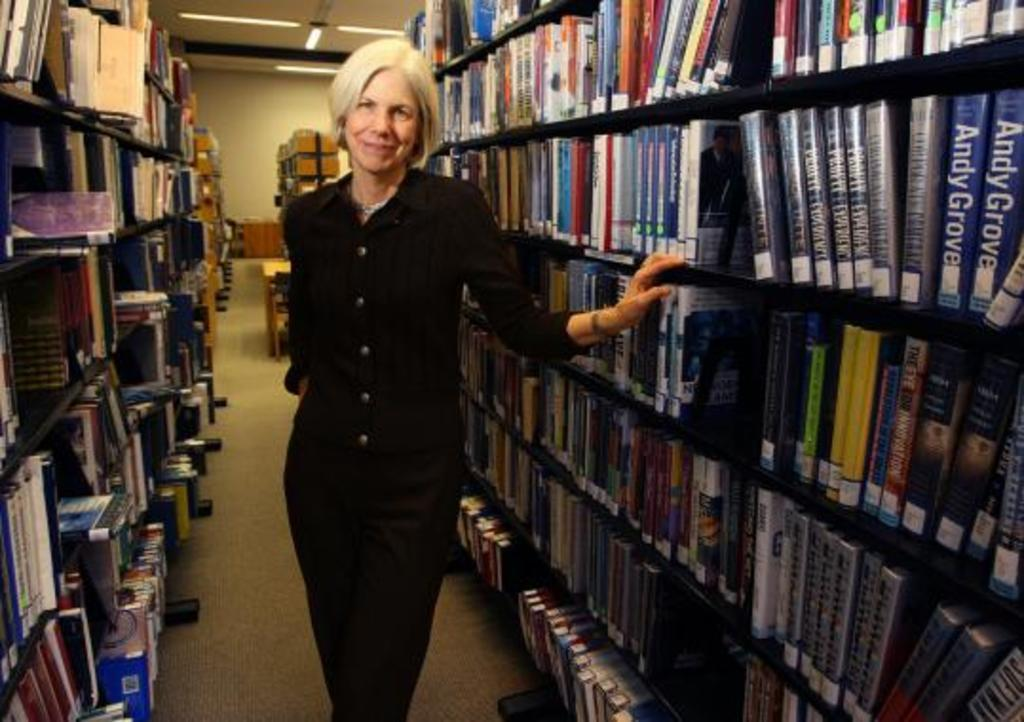<image>
Relay a brief, clear account of the picture shown. Two books with "Andy Grove" on the spine are on the shelves to the right. 